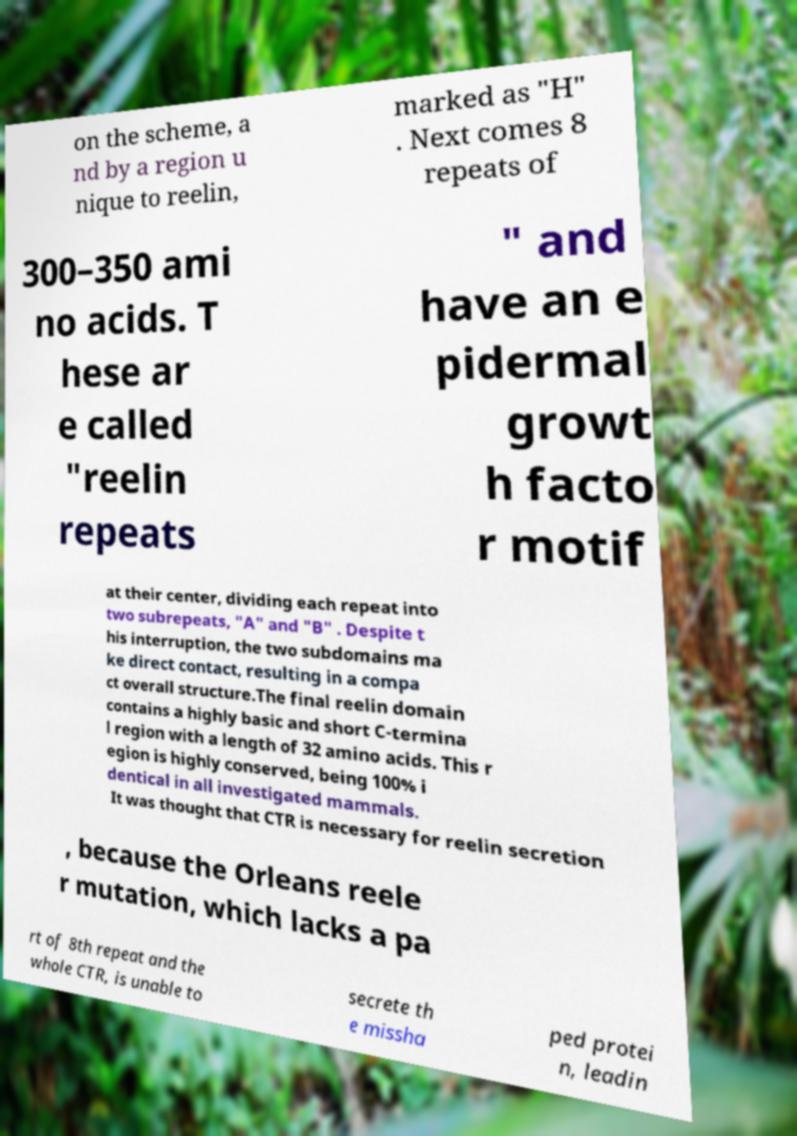Can you accurately transcribe the text from the provided image for me? on the scheme, a nd by a region u nique to reelin, marked as "H" . Next comes 8 repeats of 300–350 ami no acids. T hese ar e called "reelin repeats " and have an e pidermal growt h facto r motif at their center, dividing each repeat into two subrepeats, "A" and "B" . Despite t his interruption, the two subdomains ma ke direct contact, resulting in a compa ct overall structure.The final reelin domain contains a highly basic and short C-termina l region with a length of 32 amino acids. This r egion is highly conserved, being 100% i dentical in all investigated mammals. It was thought that CTR is necessary for reelin secretion , because the Orleans reele r mutation, which lacks a pa rt of 8th repeat and the whole CTR, is unable to secrete th e missha ped protei n, leadin 